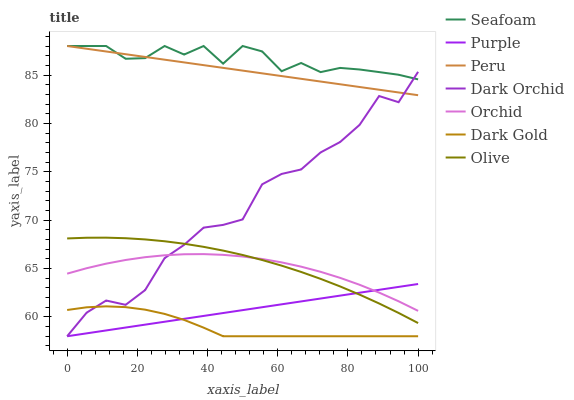Does Dark Gold have the minimum area under the curve?
Answer yes or no. Yes. Does Seafoam have the maximum area under the curve?
Answer yes or no. Yes. Does Purple have the minimum area under the curve?
Answer yes or no. No. Does Purple have the maximum area under the curve?
Answer yes or no. No. Is Peru the smoothest?
Answer yes or no. Yes. Is Dark Orchid the roughest?
Answer yes or no. Yes. Is Purple the smoothest?
Answer yes or no. No. Is Purple the roughest?
Answer yes or no. No. Does Dark Gold have the lowest value?
Answer yes or no. Yes. Does Seafoam have the lowest value?
Answer yes or no. No. Does Peru have the highest value?
Answer yes or no. Yes. Does Purple have the highest value?
Answer yes or no. No. Is Purple less than Peru?
Answer yes or no. Yes. Is Seafoam greater than Orchid?
Answer yes or no. Yes. Does Dark Gold intersect Dark Orchid?
Answer yes or no. Yes. Is Dark Gold less than Dark Orchid?
Answer yes or no. No. Is Dark Gold greater than Dark Orchid?
Answer yes or no. No. Does Purple intersect Peru?
Answer yes or no. No. 